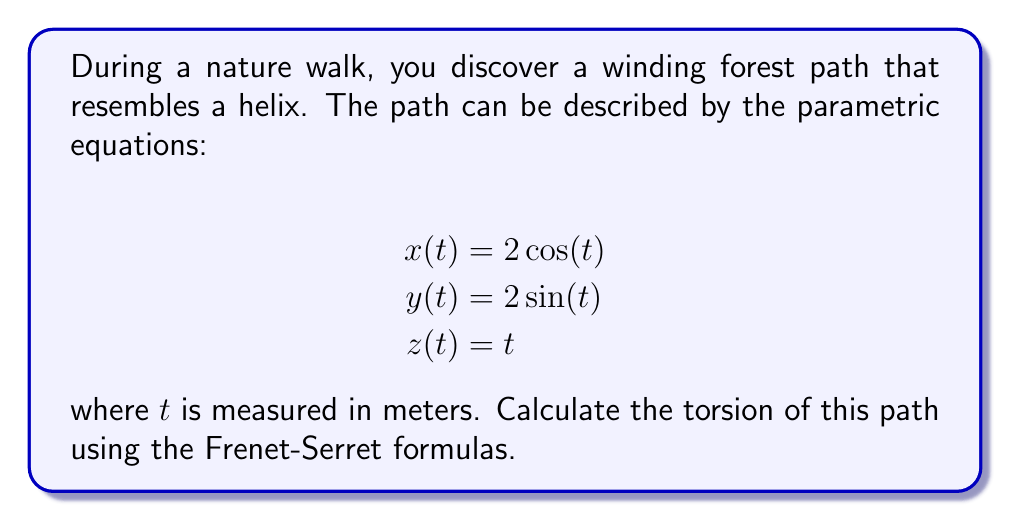Provide a solution to this math problem. To calculate the torsion of the path, we'll use the Frenet-Serret formula for torsion:

$$\tau = \frac{\mathbf{r}'(t) \cdot (\mathbf{r}''(t) \times \mathbf{r}'''(t))}{|\mathbf{r}'(t) \times \mathbf{r}''(t)|^2}$$

Step 1: Calculate $\mathbf{r}'(t)$, $\mathbf{r}''(t)$, and $\mathbf{r}'''(t)$
$\mathbf{r}'(t) = (-2\sin(t), 2\cos(t), 1)$
$\mathbf{r}''(t) = (-2\cos(t), -2\sin(t), 0)$
$\mathbf{r}'''(t) = (2\sin(t), -2\cos(t), 0)$

Step 2: Calculate $\mathbf{r}''(t) \times \mathbf{r}'''(t)$
$\mathbf{r}''(t) \times \mathbf{r}'''(t) = (0, 0, -4)$

Step 3: Calculate $\mathbf{r}'(t) \cdot (\mathbf{r}''(t) \times \mathbf{r}'''(t))$
$\mathbf{r}'(t) \cdot (\mathbf{r}''(t) \times \mathbf{r}'''(t)) = (-2\sin(t), 2\cos(t), 1) \cdot (0, 0, -4) = -4$

Step 4: Calculate $\mathbf{r}'(t) \times \mathbf{r}''(t)$
$\mathbf{r}'(t) \times \mathbf{r}''(t) = (2, 2, 4)$

Step 5: Calculate $|\mathbf{r}'(t) \times \mathbf{r}''(t)|^2$
$|\mathbf{r}'(t) \times \mathbf{r}''(t)|^2 = 2^2 + 2^2 + 4^2 = 24$

Step 6: Apply the torsion formula
$$\tau = \frac{-4}{24} = -\frac{1}{6}$$

The negative sign indicates that the helix is left-handed.
Answer: $-\frac{1}{6}$ 